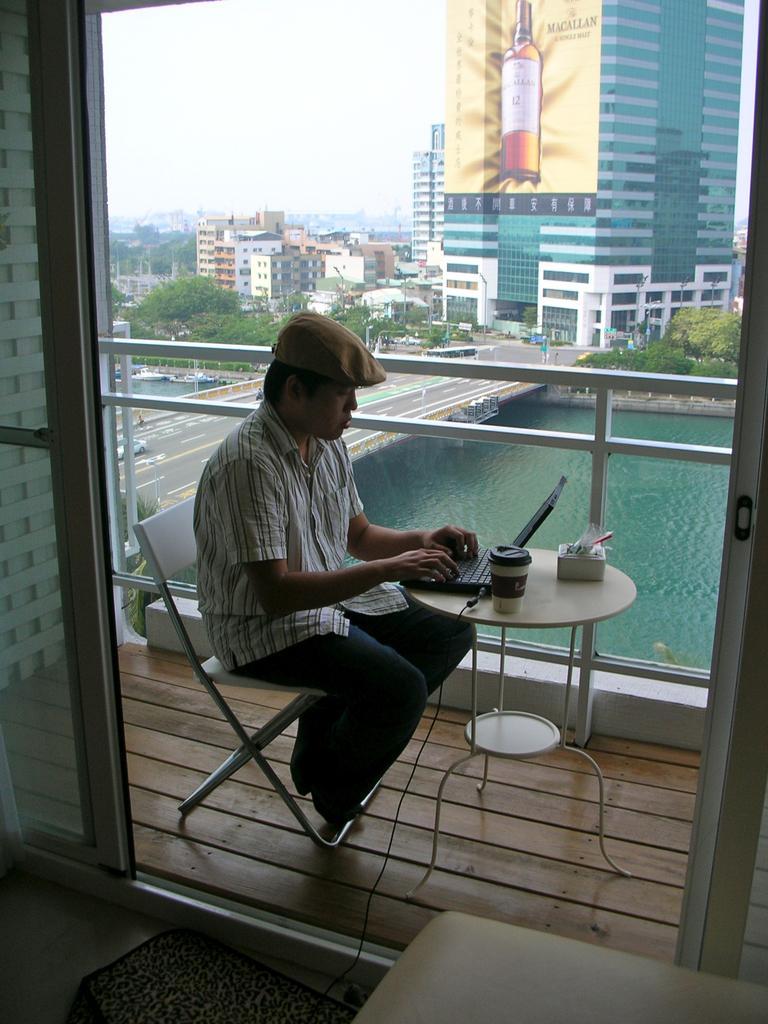How would you summarize this image in a sentence or two? in this there is a person sitting on a chair and operating the laptop. behind him there is water,road and buildings. 